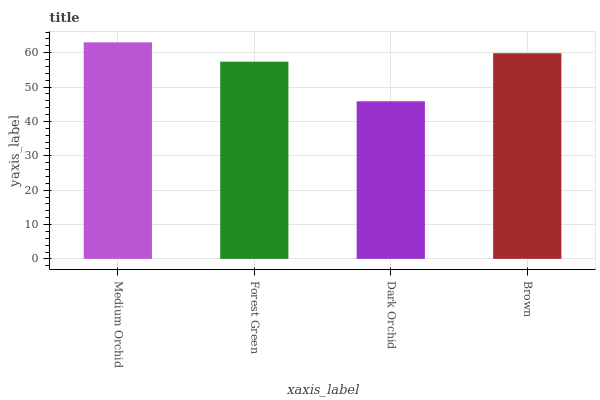Is Dark Orchid the minimum?
Answer yes or no. Yes. Is Medium Orchid the maximum?
Answer yes or no. Yes. Is Forest Green the minimum?
Answer yes or no. No. Is Forest Green the maximum?
Answer yes or no. No. Is Medium Orchid greater than Forest Green?
Answer yes or no. Yes. Is Forest Green less than Medium Orchid?
Answer yes or no. Yes. Is Forest Green greater than Medium Orchid?
Answer yes or no. No. Is Medium Orchid less than Forest Green?
Answer yes or no. No. Is Brown the high median?
Answer yes or no. Yes. Is Forest Green the low median?
Answer yes or no. Yes. Is Dark Orchid the high median?
Answer yes or no. No. Is Brown the low median?
Answer yes or no. No. 